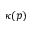<formula> <loc_0><loc_0><loc_500><loc_500>\kappa ( p )</formula> 